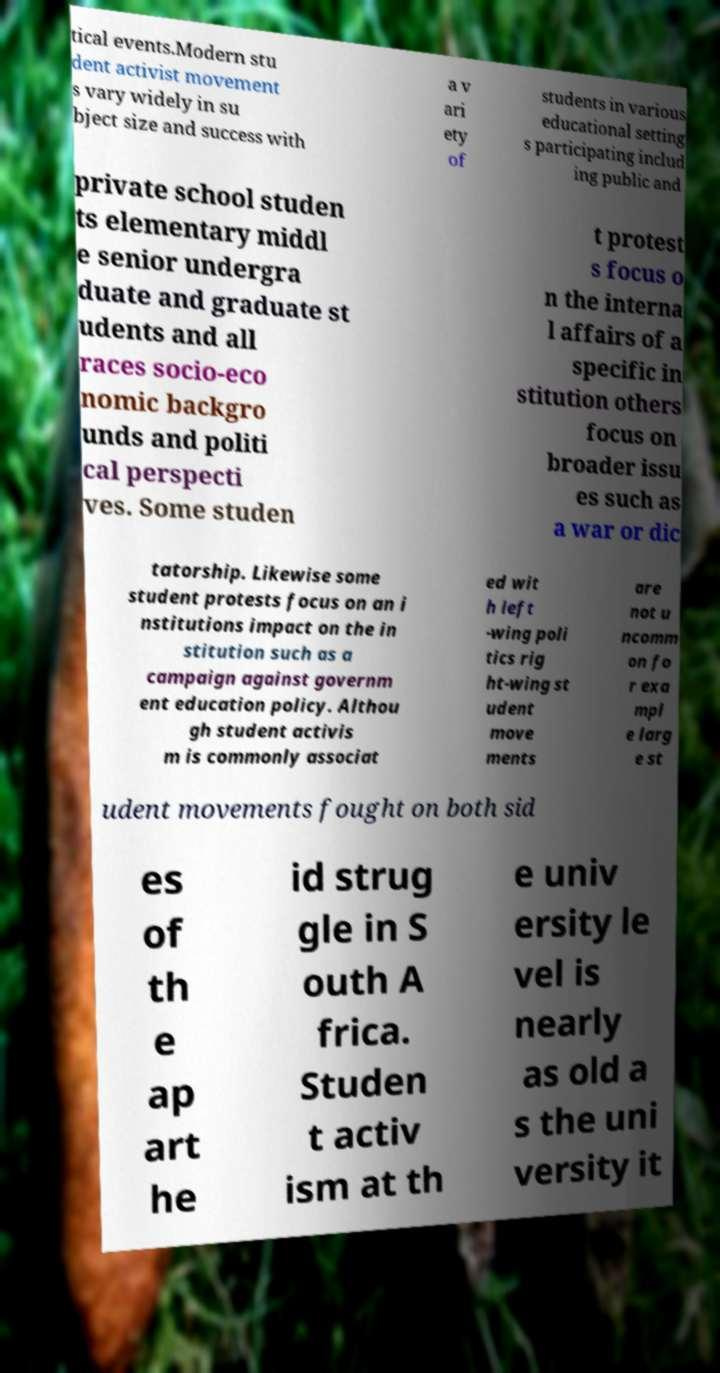Can you accurately transcribe the text from the provided image for me? tical events.Modern stu dent activist movement s vary widely in su bject size and success with a v ari ety of students in various educational setting s participating includ ing public and private school studen ts elementary middl e senior undergra duate and graduate st udents and all races socio-eco nomic backgro unds and politi cal perspecti ves. Some studen t protest s focus o n the interna l affairs of a specific in stitution others focus on broader issu es such as a war or dic tatorship. Likewise some student protests focus on an i nstitutions impact on the in stitution such as a campaign against governm ent education policy. Althou gh student activis m is commonly associat ed wit h left -wing poli tics rig ht-wing st udent move ments are not u ncomm on fo r exa mpl e larg e st udent movements fought on both sid es of th e ap art he id strug gle in S outh A frica. Studen t activ ism at th e univ ersity le vel is nearly as old a s the uni versity it 